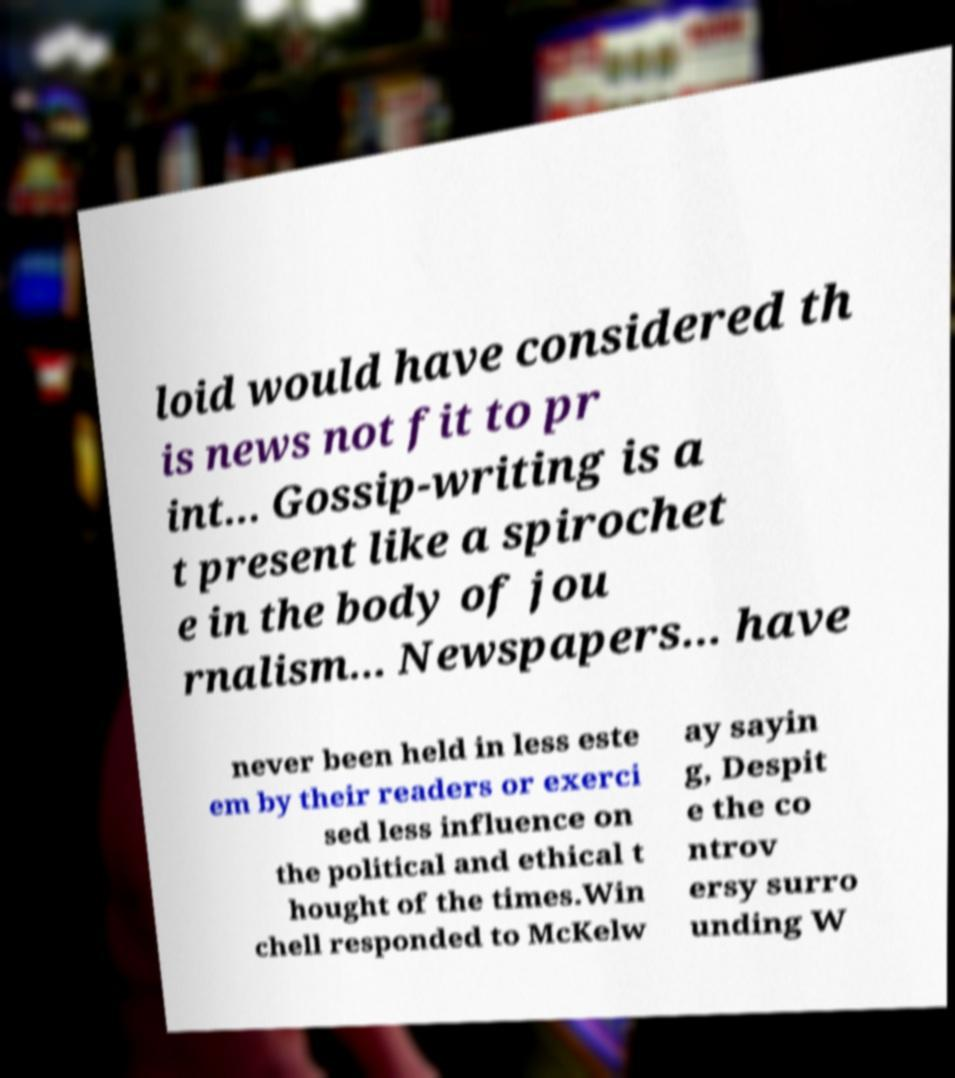Can you accurately transcribe the text from the provided image for me? loid would have considered th is news not fit to pr int... Gossip-writing is a t present like a spirochet e in the body of jou rnalism... Newspapers... have never been held in less este em by their readers or exerci sed less influence on the political and ethical t hought of the times.Win chell responded to McKelw ay sayin g, Despit e the co ntrov ersy surro unding W 